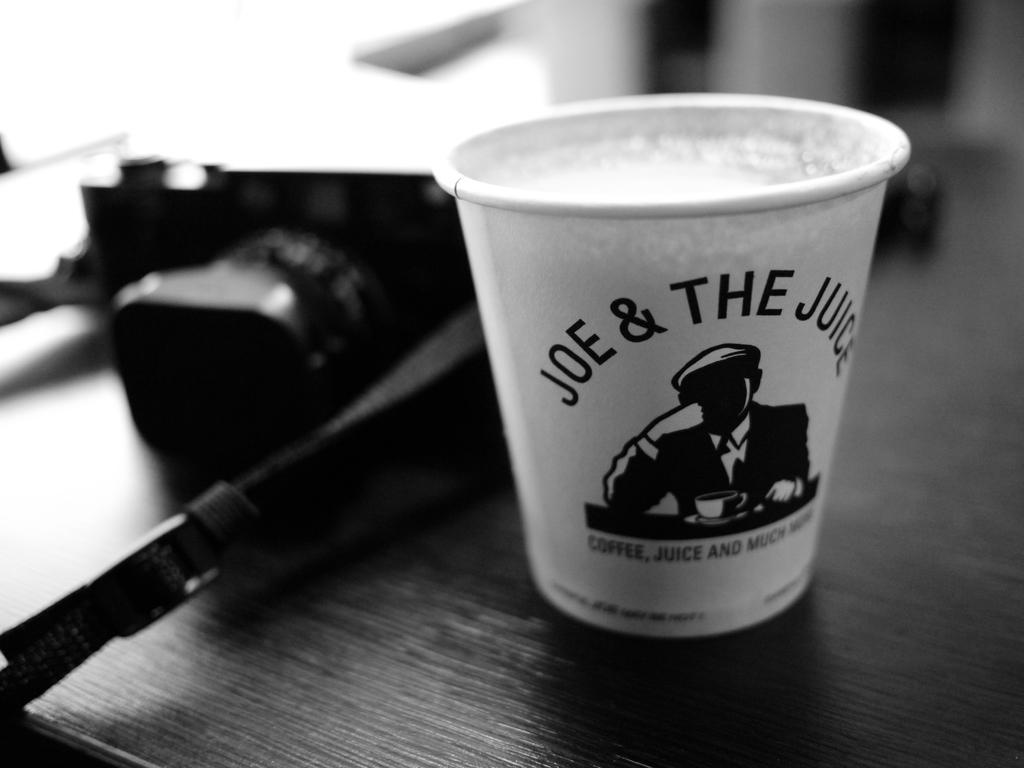<image>
Provide a brief description of the given image. A cup on a table with Joe & The Juice on it. 